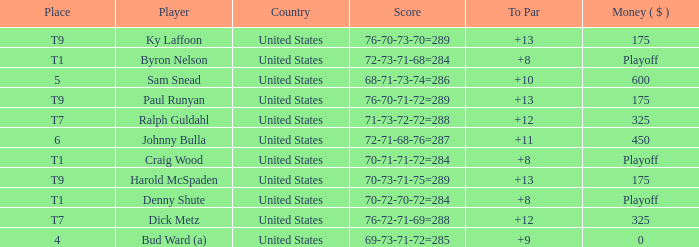What's the money that Sam Snead won? 600.0. 